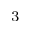Convert formula to latex. <formula><loc_0><loc_0><loc_500><loc_500>^ { 3 }</formula> 